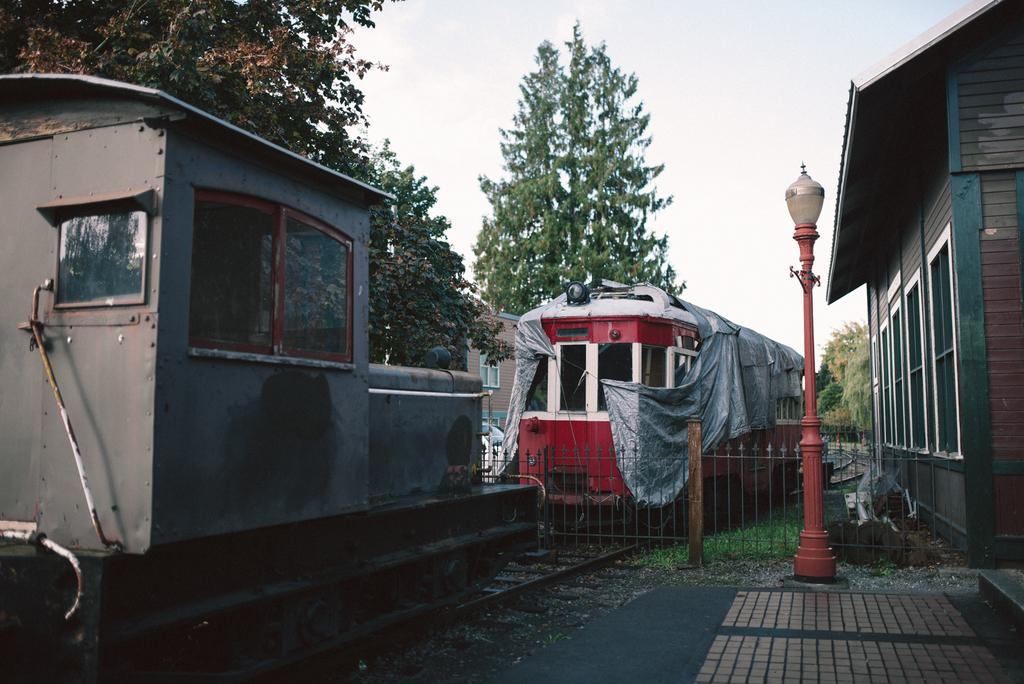What type of vehicles can be seen on the track in the image? There are trains on the track in the image. What can be seen near the track in the image? There is railing visible in the image. What structure is present in the image? There is a light pole in the image. What type of surface can be seen in the image? There is a path in the image. What type of buildings are visible in the image? There are houses in the image. What type of vegetation is present in the image? There are trees and grass in the image. What else can be seen in the image? There are a few unspecified objects in the image. What is visible in the background of the image? The sky is visible in the background of the image. How does the mind of the train engineer feel while operating the train in the image? There is no information about the train engineer's mind in the image, so it cannot be determined. What type of stream is visible in the image? There is no stream present in the image. 